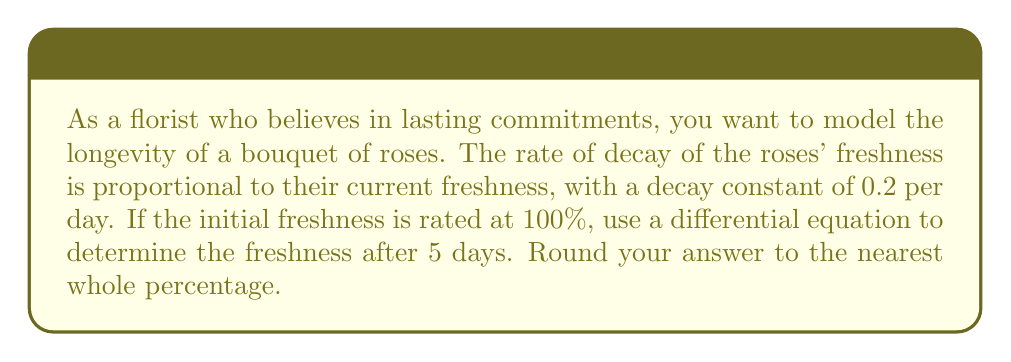Solve this math problem. Let's approach this step-by-step:

1) Let $F(t)$ represent the freshness of the roses at time $t$ in days.

2) The rate of decay is proportional to the current freshness, which we can express as a differential equation:

   $$\frac{dF}{dt} = -kF$$

   where $k$ is the decay constant, given as 0.2 per day.

3) This is a separable differential equation. We can solve it as follows:

   $$\frac{dF}{F} = -k dt$$

4) Integrating both sides:

   $$\int \frac{dF}{F} = -k \int dt$$

   $$\ln|F| = -kt + C$$

5) Solving for $F$:

   $$F(t) = e^{-kt + C} = Ae^{-kt}$$

   where $A = e^C$ is a constant.

6) We're given that the initial freshness is 100%, so $F(0) = 100$. Using this initial condition:

   $$100 = Ae^{-k(0)} = A$$

7) Therefore, our solution is:

   $$F(t) = 100e^{-0.2t}$$

8) To find the freshness after 5 days, we evaluate $F(5)$:

   $$F(5) = 100e^{-0.2(5)} = 100e^{-1} \approx 36.79\%$$

9) Rounding to the nearest whole percentage, we get 37%.
Answer: 37% 